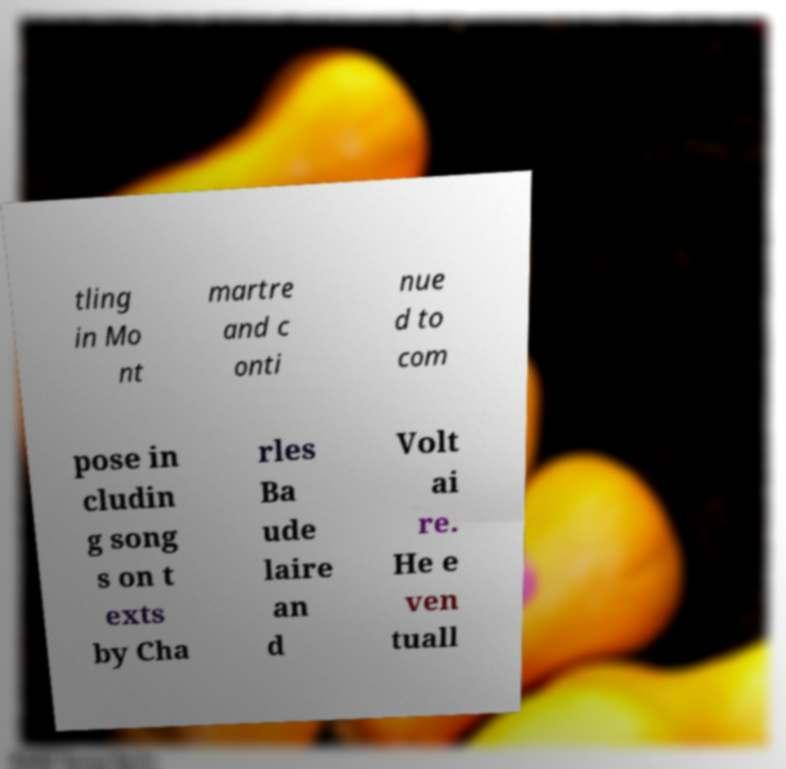What messages or text are displayed in this image? I need them in a readable, typed format. tling in Mo nt martre and c onti nue d to com pose in cludin g song s on t exts by Cha rles Ba ude laire an d Volt ai re. He e ven tuall 